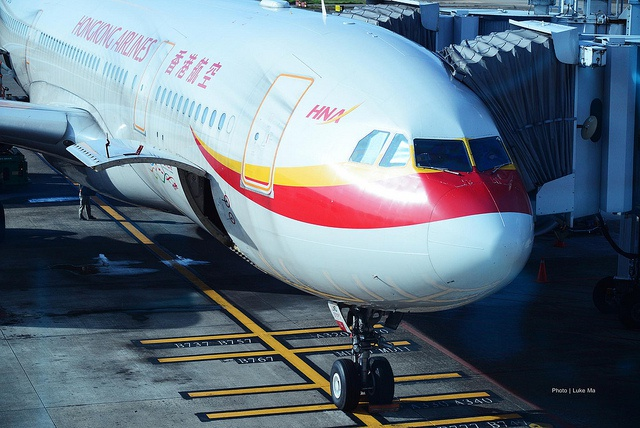Describe the objects in this image and their specific colors. I can see airplane in lightblue, black, and darkgray tones and people in lightblue, black, gray, and darkblue tones in this image. 